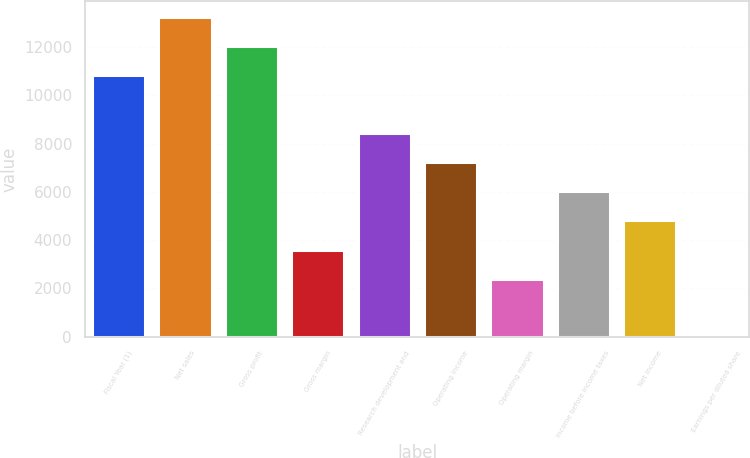<chart> <loc_0><loc_0><loc_500><loc_500><bar_chart><fcel>Fiscal Year (1)<fcel>Net sales<fcel>Gross profit<fcel>Gross margin<fcel>Research development and<fcel>Operating income<fcel>Operating margin<fcel>Income before income taxes<fcel>Net income<fcel>Earnings per diluted share<nl><fcel>10838.7<fcel>13247.3<fcel>12043<fcel>3613.05<fcel>8430.17<fcel>7225.89<fcel>2408.77<fcel>6021.61<fcel>4817.33<fcel>0.21<nl></chart> 